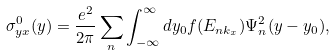Convert formula to latex. <formula><loc_0><loc_0><loc_500><loc_500>\sigma _ { y x } ^ { 0 } ( y ) = \frac { e ^ { 2 } } { 2 \pi } \sum _ { n } \int _ { - \infty } ^ { \infty } d y _ { 0 } f ( E _ { n k _ { x } } ) \Psi _ { n } ^ { 2 } ( y - y _ { 0 } ) ,</formula> 